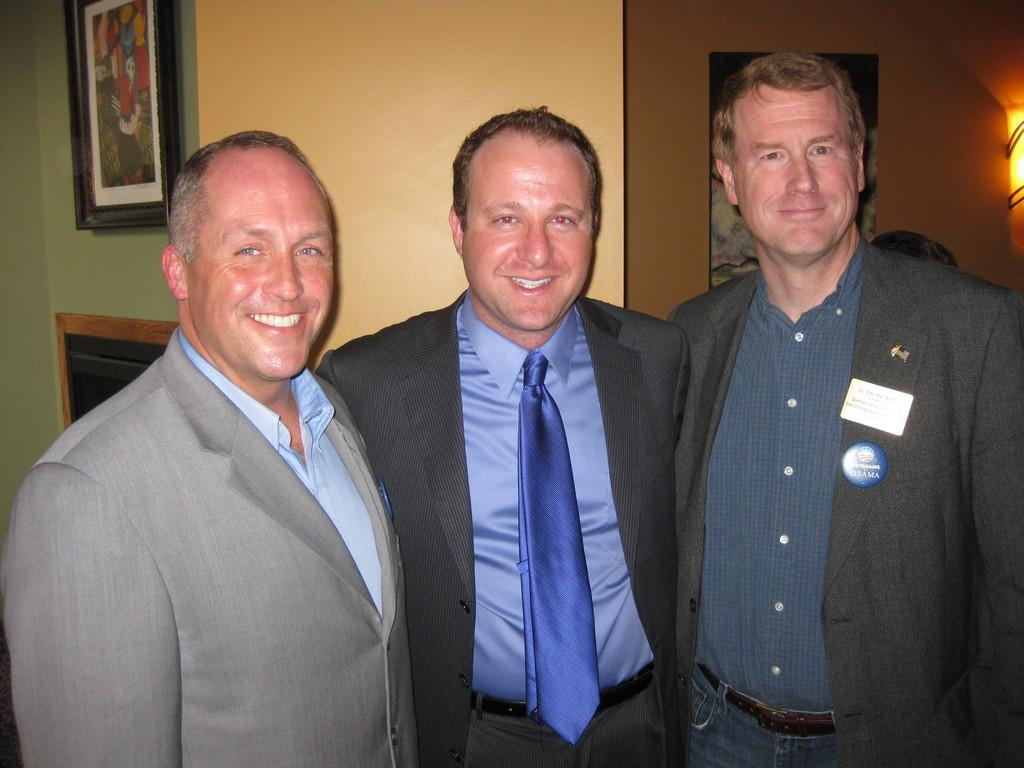How many people are in the image? There are three men in the image. What are the men doing in the image? The men are standing and smiling. What can be seen in the background of the image? There is a frame on a wall and a light in the background of the image. What type of leather is being used by the fowl in the image? There is no fowl or leather present in the image. How does the beggar in the image interact with the men? There is no beggar present in the image; it features three men standing and smiling. 